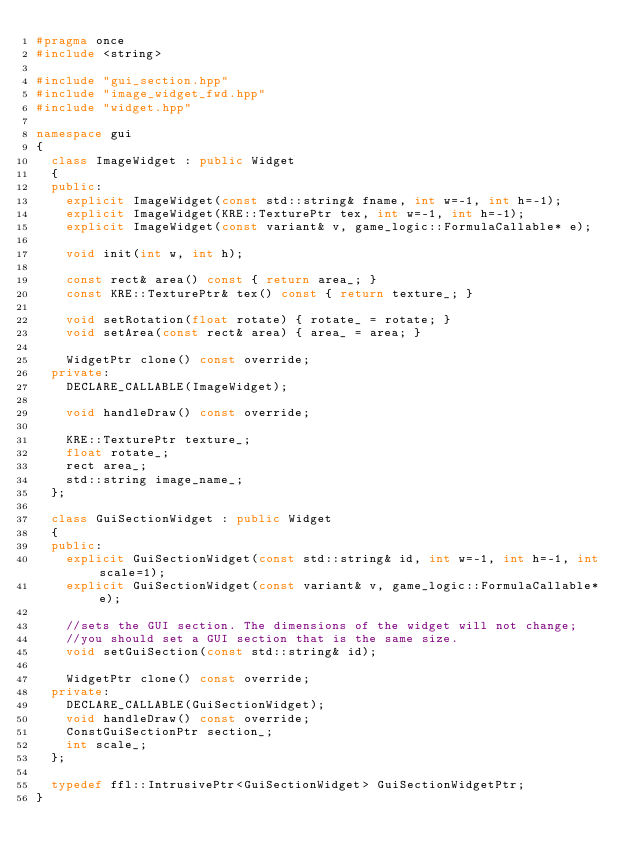Convert code to text. <code><loc_0><loc_0><loc_500><loc_500><_C++_>#pragma once
#include <string>

#include "gui_section.hpp"
#include "image_widget_fwd.hpp"
#include "widget.hpp"

namespace gui 
{
	class ImageWidget : public Widget
	{
	public:
		explicit ImageWidget(const std::string& fname, int w=-1, int h=-1);
		explicit ImageWidget(KRE::TexturePtr tex, int w=-1, int h=-1);
		explicit ImageWidget(const variant& v, game_logic::FormulaCallable* e);

		void init(int w, int h);

		const rect& area() const { return area_; }
		const KRE::TexturePtr& tex() const { return texture_; }

		void setRotation(float rotate) { rotate_ = rotate; }
		void setArea(const rect& area) { area_ = area; }

		WidgetPtr clone() const override;
	private:
		DECLARE_CALLABLE(ImageWidget);

		void handleDraw() const override;

		KRE::TexturePtr texture_;
		float rotate_;
		rect area_;
		std::string image_name_;
	};

	class GuiSectionWidget : public Widget
	{
	public:
		explicit GuiSectionWidget(const std::string& id, int w=-1, int h=-1, int scale=1);
		explicit GuiSectionWidget(const variant& v, game_logic::FormulaCallable* e);

		//sets the GUI section. The dimensions of the widget will not change;
		//you should set a GUI section that is the same size.
		void setGuiSection(const std::string& id);

		WidgetPtr clone() const override;
	private:
		DECLARE_CALLABLE(GuiSectionWidget);
		void handleDraw() const override;
		ConstGuiSectionPtr section_;
		int scale_;
	};

	typedef ffl::IntrusivePtr<GuiSectionWidget> GuiSectionWidgetPtr;
}
</code> 